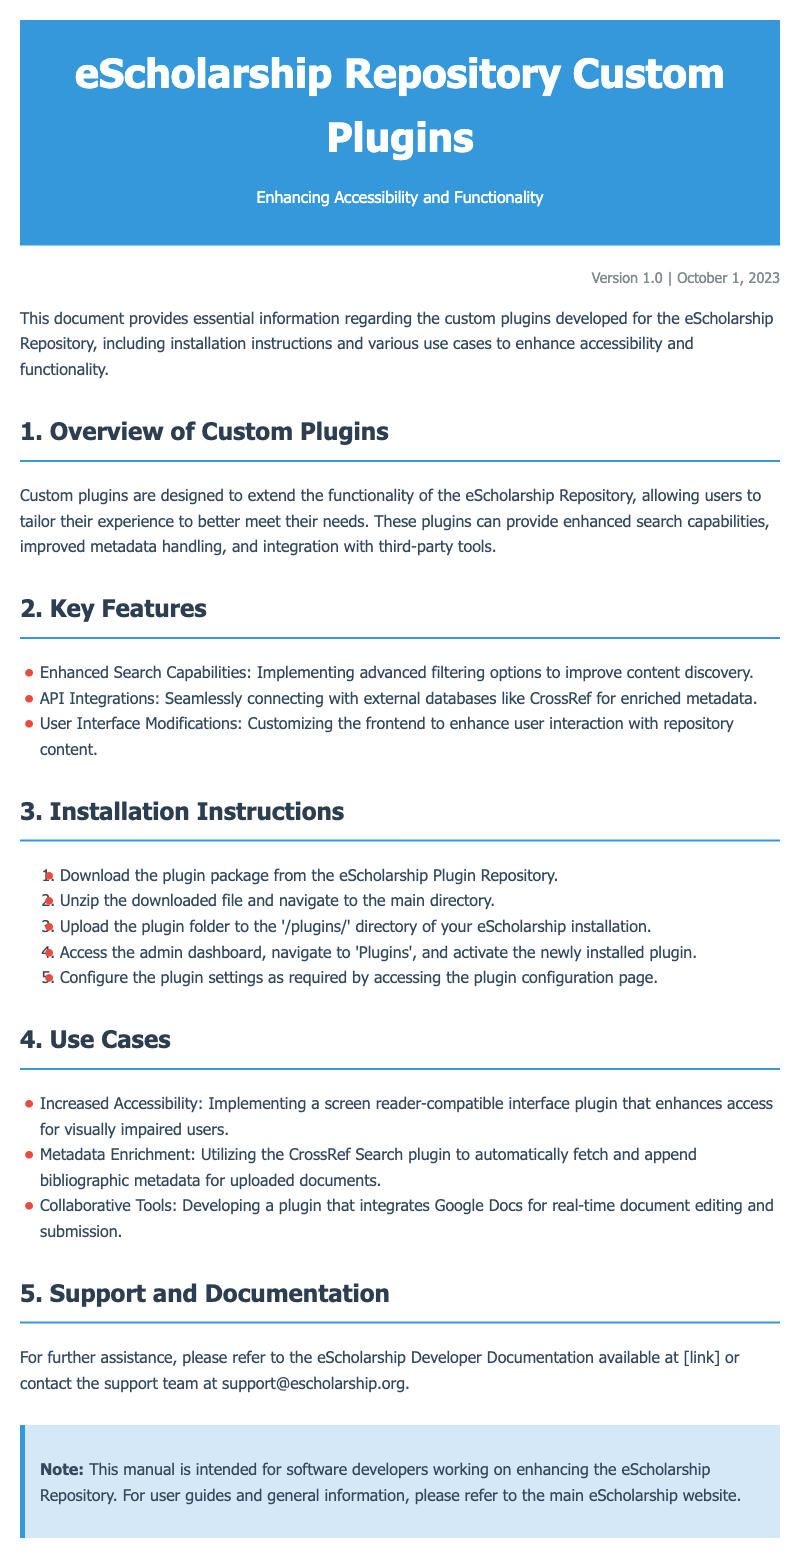What is the version of the manual? The version of the manual is stated in the documentation as "Version 1.0".
Answer: Version 1.0 When was the manual published? The document mentions that it was published on October 1, 2023.
Answer: October 1, 2023 What is one of the key features of the plugins? The document lists "Enhanced Search Capabilities" as a key feature.
Answer: Enhanced Search Capabilities How many installation instructions are provided? There are five steps outlined for installation in the document.
Answer: Five What is the purpose of the CrossRef Search plugin? The document states that it is used for metadata enrichment.
Answer: Metadata enrichment Which section discusses user interface modifications? The "Key Features" section covers user interface modifications.
Answer: Key Features What type of users will benefit from the accessibility plugin? The document indicates that visually impaired users will benefit.
Answer: Visually impaired users What email is provided for support inquiries? The support team's email provided in the document is needed for assistance.
Answer: support@escholarship.org 